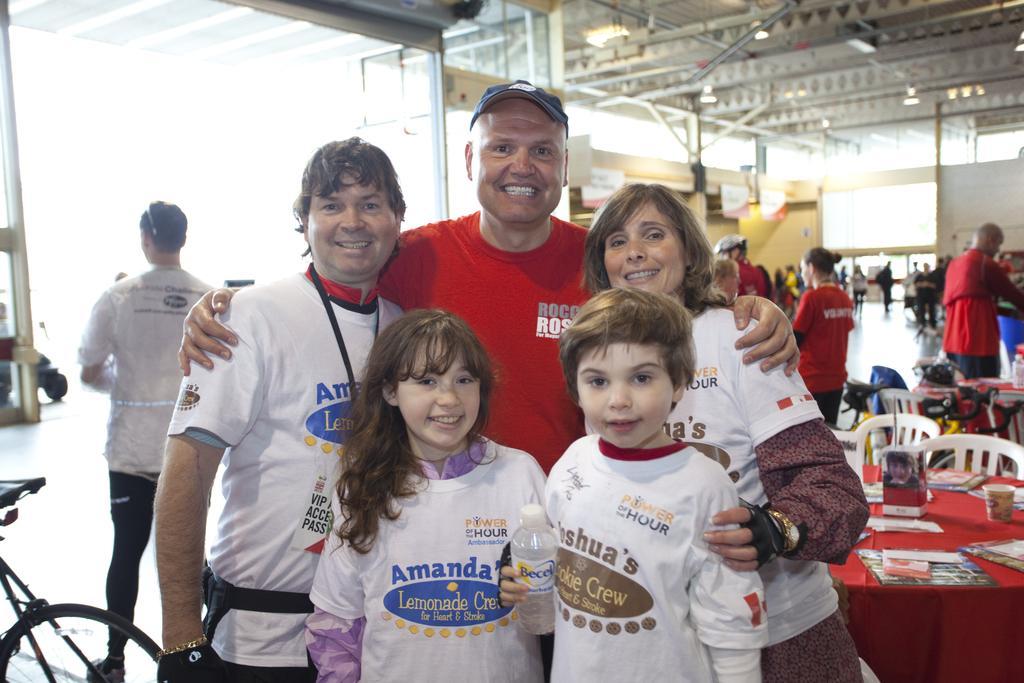Could you give a brief overview of what you see in this image? In this picture I can see five persons standing and smiling, there are some objects on the table, there are chairs, bicycles, boards, lights and some other objects, there are group of people standing. 